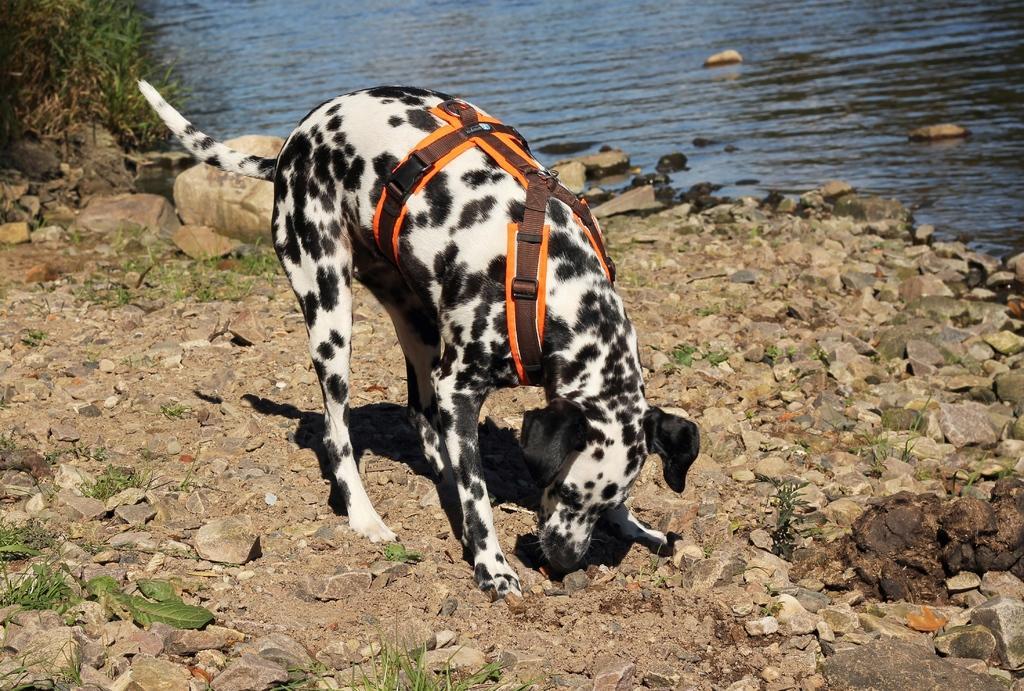Please provide a concise description of this image. In this image in the foreground I can see a dog wearing a belt, there are many rocks and in the background we can see the water. 